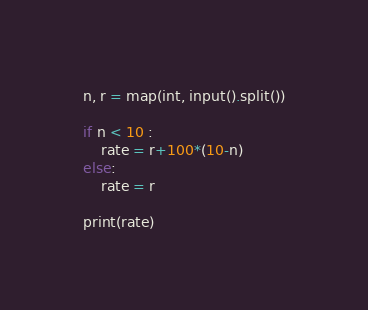Convert code to text. <code><loc_0><loc_0><loc_500><loc_500><_Python_>n, r = map(int, input().split())

if n < 10 :
    rate = r+100*(10-n)
else:
    rate = r

print(rate)</code> 